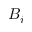Convert formula to latex. <formula><loc_0><loc_0><loc_500><loc_500>B _ { i }</formula> 